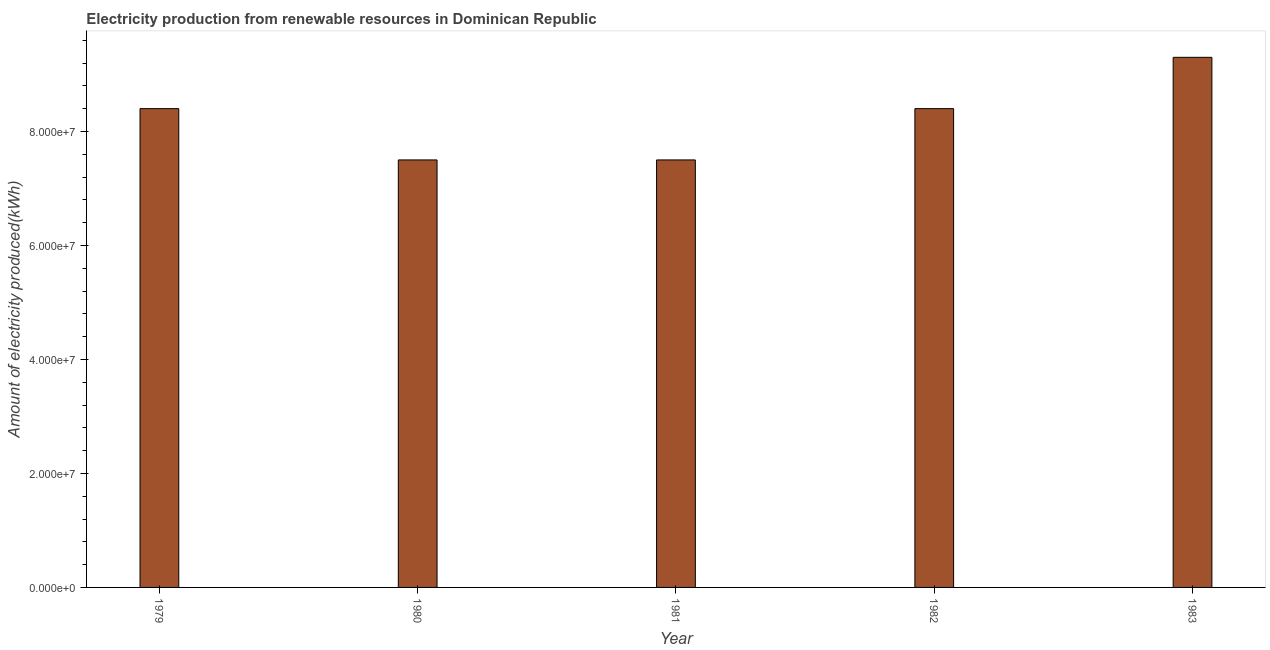Does the graph contain any zero values?
Offer a very short reply. No. What is the title of the graph?
Your answer should be very brief. Electricity production from renewable resources in Dominican Republic. What is the label or title of the Y-axis?
Ensure brevity in your answer.  Amount of electricity produced(kWh). What is the amount of electricity produced in 1982?
Provide a succinct answer. 8.40e+07. Across all years, what is the maximum amount of electricity produced?
Give a very brief answer. 9.30e+07. Across all years, what is the minimum amount of electricity produced?
Give a very brief answer. 7.50e+07. What is the sum of the amount of electricity produced?
Provide a succinct answer. 4.11e+08. What is the average amount of electricity produced per year?
Your response must be concise. 8.22e+07. What is the median amount of electricity produced?
Your answer should be compact. 8.40e+07. In how many years, is the amount of electricity produced greater than 20000000 kWh?
Make the answer very short. 5. Do a majority of the years between 1983 and 1980 (inclusive) have amount of electricity produced greater than 44000000 kWh?
Provide a succinct answer. Yes. What is the ratio of the amount of electricity produced in 1981 to that in 1982?
Your response must be concise. 0.89. Is the difference between the amount of electricity produced in 1979 and 1981 greater than the difference between any two years?
Make the answer very short. No. What is the difference between the highest and the second highest amount of electricity produced?
Your answer should be compact. 9.00e+06. Is the sum of the amount of electricity produced in 1979 and 1982 greater than the maximum amount of electricity produced across all years?
Offer a terse response. Yes. What is the difference between the highest and the lowest amount of electricity produced?
Offer a very short reply. 1.80e+07. In how many years, is the amount of electricity produced greater than the average amount of electricity produced taken over all years?
Your answer should be very brief. 3. What is the Amount of electricity produced(kWh) of 1979?
Make the answer very short. 8.40e+07. What is the Amount of electricity produced(kWh) in 1980?
Keep it short and to the point. 7.50e+07. What is the Amount of electricity produced(kWh) in 1981?
Provide a succinct answer. 7.50e+07. What is the Amount of electricity produced(kWh) in 1982?
Keep it short and to the point. 8.40e+07. What is the Amount of electricity produced(kWh) of 1983?
Make the answer very short. 9.30e+07. What is the difference between the Amount of electricity produced(kWh) in 1979 and 1980?
Your answer should be very brief. 9.00e+06. What is the difference between the Amount of electricity produced(kWh) in 1979 and 1981?
Keep it short and to the point. 9.00e+06. What is the difference between the Amount of electricity produced(kWh) in 1979 and 1982?
Your answer should be compact. 0. What is the difference between the Amount of electricity produced(kWh) in 1979 and 1983?
Ensure brevity in your answer.  -9.00e+06. What is the difference between the Amount of electricity produced(kWh) in 1980 and 1982?
Offer a very short reply. -9.00e+06. What is the difference between the Amount of electricity produced(kWh) in 1980 and 1983?
Your response must be concise. -1.80e+07. What is the difference between the Amount of electricity produced(kWh) in 1981 and 1982?
Your answer should be very brief. -9.00e+06. What is the difference between the Amount of electricity produced(kWh) in 1981 and 1983?
Provide a succinct answer. -1.80e+07. What is the difference between the Amount of electricity produced(kWh) in 1982 and 1983?
Provide a short and direct response. -9.00e+06. What is the ratio of the Amount of electricity produced(kWh) in 1979 to that in 1980?
Your response must be concise. 1.12. What is the ratio of the Amount of electricity produced(kWh) in 1979 to that in 1981?
Provide a short and direct response. 1.12. What is the ratio of the Amount of electricity produced(kWh) in 1979 to that in 1982?
Offer a very short reply. 1. What is the ratio of the Amount of electricity produced(kWh) in 1979 to that in 1983?
Your answer should be very brief. 0.9. What is the ratio of the Amount of electricity produced(kWh) in 1980 to that in 1981?
Your answer should be very brief. 1. What is the ratio of the Amount of electricity produced(kWh) in 1980 to that in 1982?
Your answer should be compact. 0.89. What is the ratio of the Amount of electricity produced(kWh) in 1980 to that in 1983?
Provide a short and direct response. 0.81. What is the ratio of the Amount of electricity produced(kWh) in 1981 to that in 1982?
Your answer should be compact. 0.89. What is the ratio of the Amount of electricity produced(kWh) in 1981 to that in 1983?
Keep it short and to the point. 0.81. What is the ratio of the Amount of electricity produced(kWh) in 1982 to that in 1983?
Ensure brevity in your answer.  0.9. 